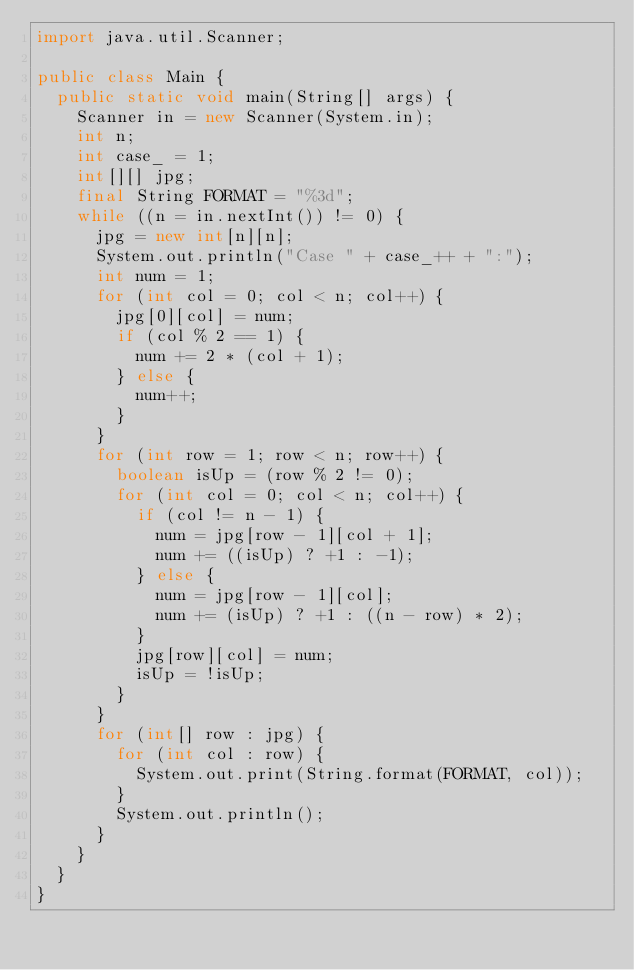Convert code to text. <code><loc_0><loc_0><loc_500><loc_500><_Java_>import java.util.Scanner;

public class Main {
	public static void main(String[] args) {
		Scanner in = new Scanner(System.in);
		int n;
		int case_ = 1;
		int[][] jpg;
		final String FORMAT = "%3d";
		while ((n = in.nextInt()) != 0) {
			jpg = new int[n][n];
			System.out.println("Case " + case_++ + ":");
			int num = 1;
			for (int col = 0; col < n; col++) {
				jpg[0][col] = num;
				if (col % 2 == 1) {
					num += 2 * (col + 1);
				} else {
					num++;
				}
			}
			for (int row = 1; row < n; row++) {
				boolean isUp = (row % 2 != 0);
				for (int col = 0; col < n; col++) {
					if (col != n - 1) {
						num = jpg[row - 1][col + 1];
						num += ((isUp) ? +1 : -1);
					} else {
						num = jpg[row - 1][col];
						num += (isUp) ? +1 : ((n - row) * 2);
					}
					jpg[row][col] = num;
					isUp = !isUp;
				}
			}
			for (int[] row : jpg) {
				for (int col : row) {
					System.out.print(String.format(FORMAT, col));
				}
				System.out.println();
			}
		}
	}
}</code> 